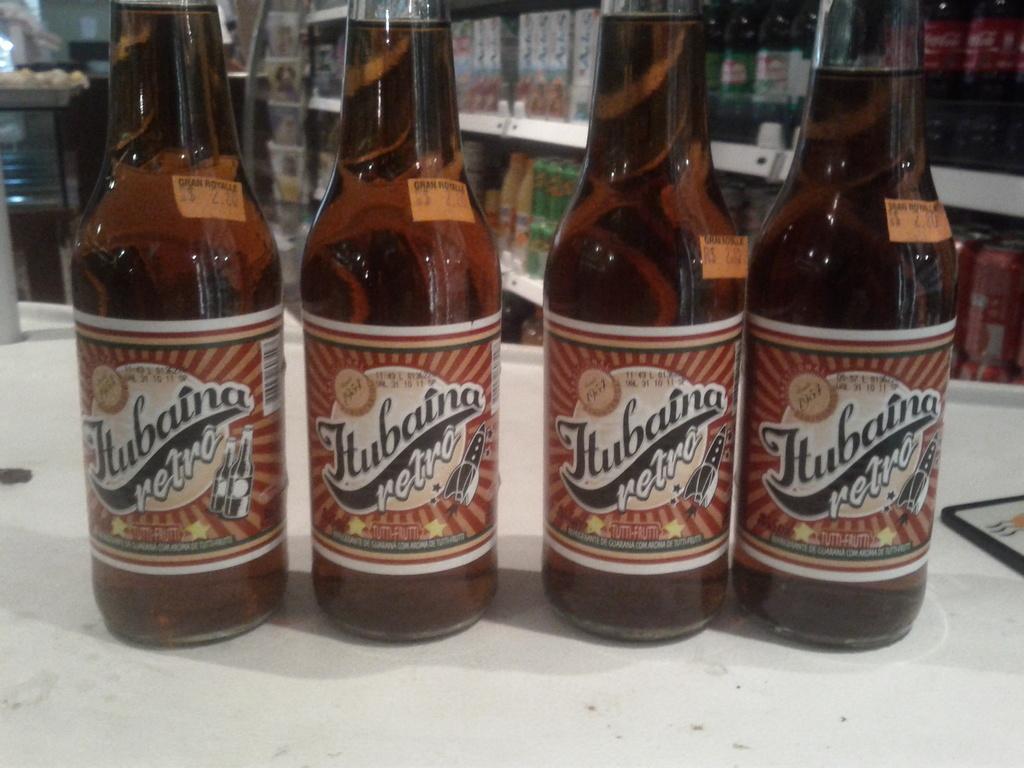What is the name of this beer?
Offer a very short reply. Hubaina retro. 